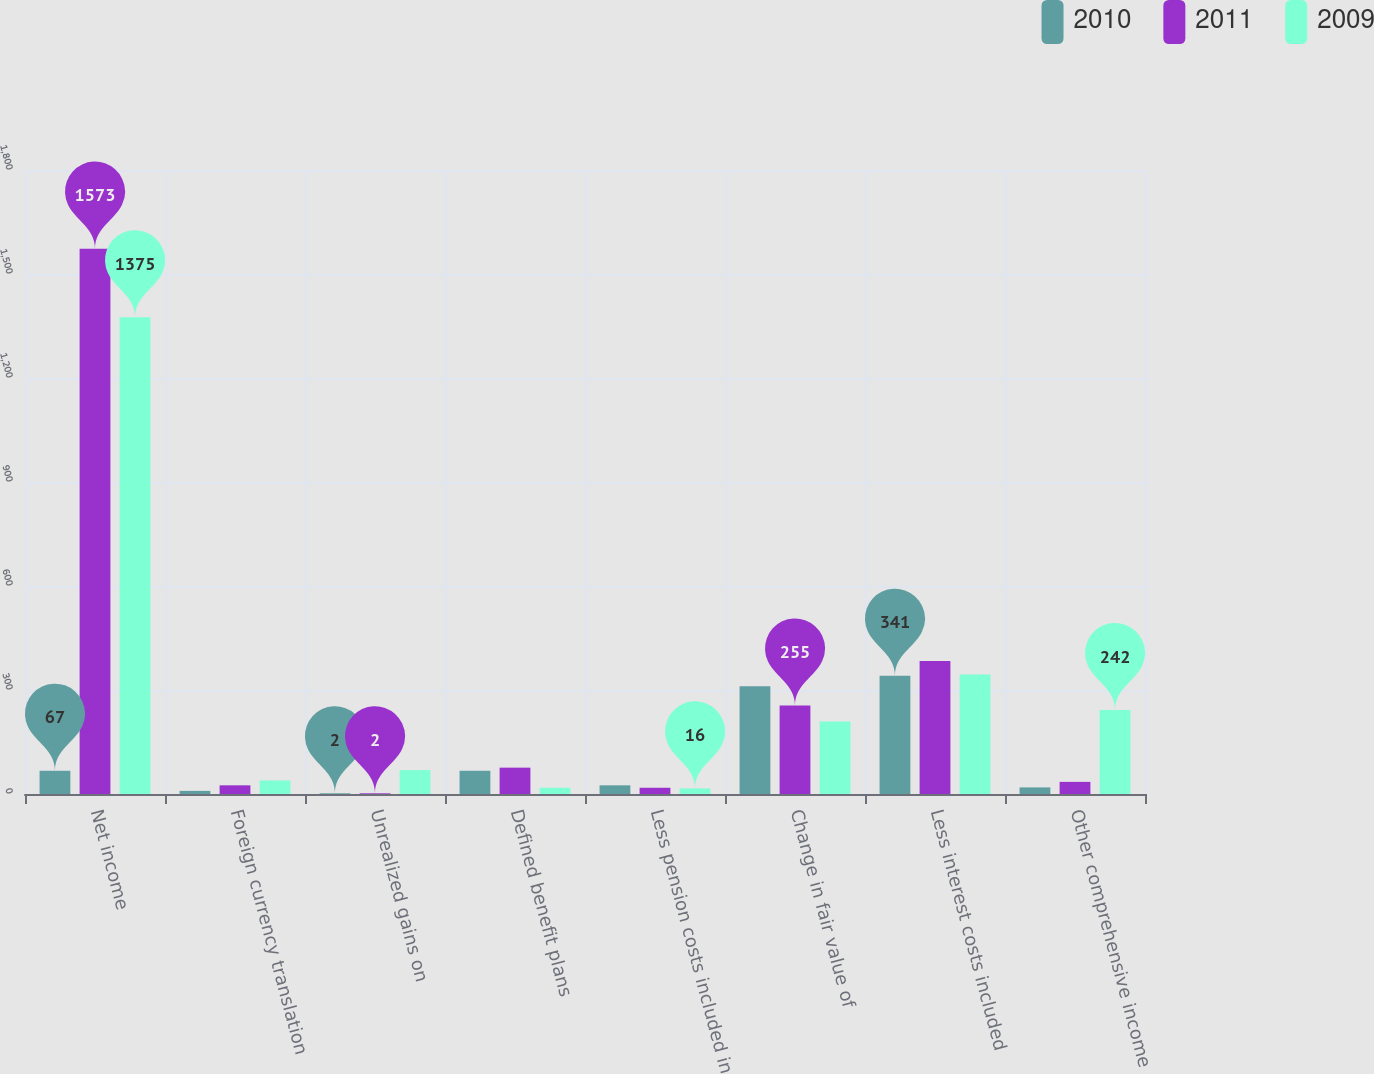<chart> <loc_0><loc_0><loc_500><loc_500><stacked_bar_chart><ecel><fcel>Net income<fcel>Foreign currency translation<fcel>Unrealized gains on<fcel>Defined benefit plans<fcel>Less pension costs included in<fcel>Change in fair value of<fcel>Less interest costs included<fcel>Other comprehensive income<nl><fcel>2010<fcel>67<fcel>9<fcel>2<fcel>67<fcel>25<fcel>311<fcel>341<fcel>19<nl><fcel>2011<fcel>1573<fcel>25<fcel>2<fcel>76<fcel>18<fcel>255<fcel>384<fcel>35<nl><fcel>2009<fcel>1375<fcel>39<fcel>69<fcel>18<fcel>16<fcel>209<fcel>345<fcel>242<nl></chart> 